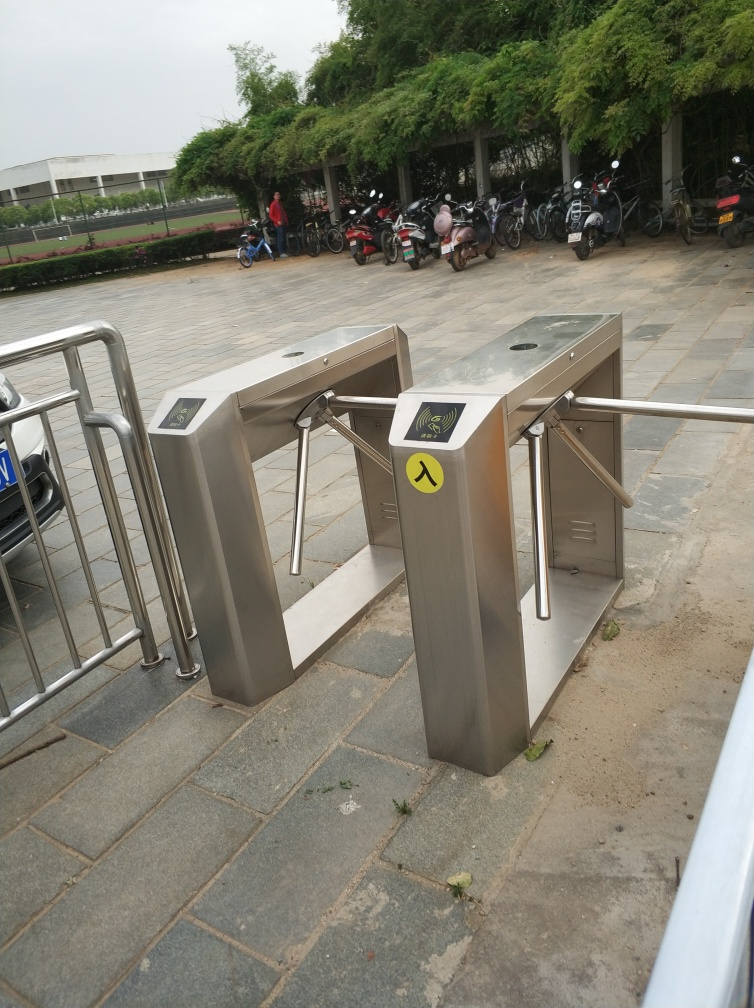Can you tell me what the purpose of this structure is? The structure in the image appears to be an access control gate, often used in places like metro stations, amusement parks, or secure facilities to regulate the flow of people. It requires a pass or ticket to be scanned for the gates to open, allowing one person through at a time as a security measure to prevent unauthorized access. 